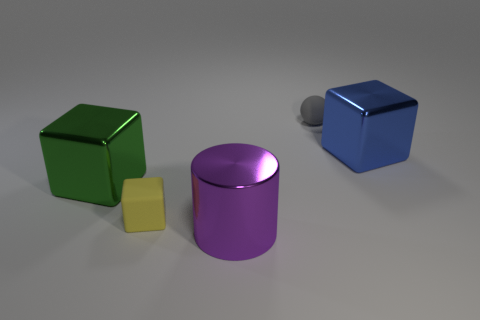Add 3 big green shiny cylinders. How many objects exist? 8 Subtract all blocks. How many objects are left? 2 Subtract all purple metal things. Subtract all gray matte balls. How many objects are left? 3 Add 1 large green metal cubes. How many large green metal cubes are left? 2 Add 4 purple metallic objects. How many purple metallic objects exist? 5 Subtract 0 red cylinders. How many objects are left? 5 